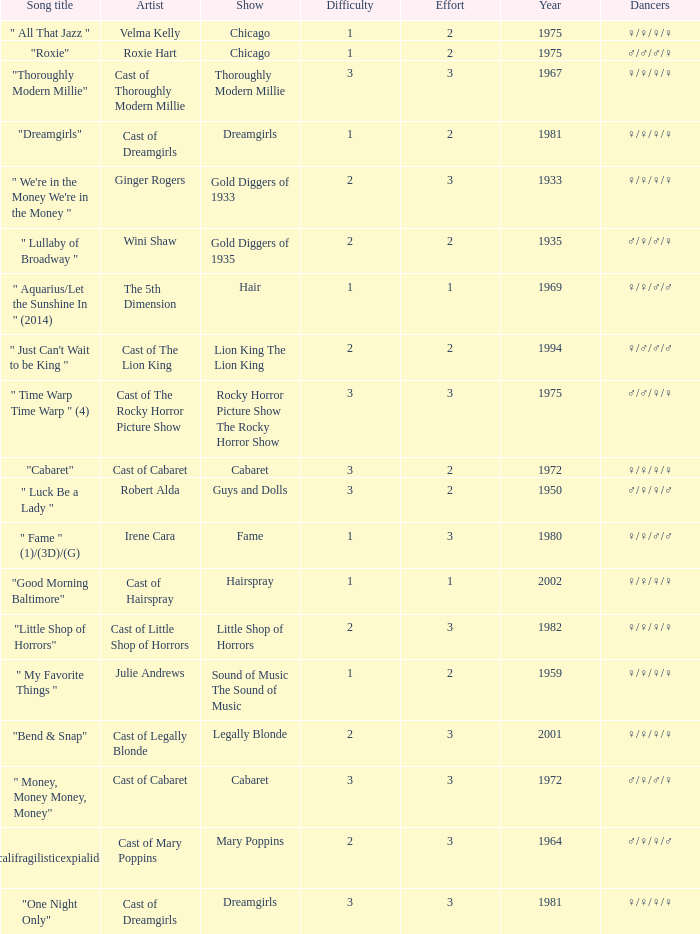How many shows were in 1994? 1.0. 